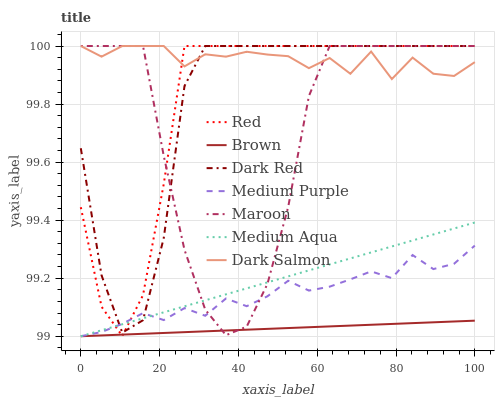Does Dark Red have the minimum area under the curve?
Answer yes or no. No. Does Dark Red have the maximum area under the curve?
Answer yes or no. No. Is Dark Red the smoothest?
Answer yes or no. No. Is Dark Red the roughest?
Answer yes or no. No. Does Dark Red have the lowest value?
Answer yes or no. No. Does Medium Purple have the highest value?
Answer yes or no. No. Is Brown less than Dark Red?
Answer yes or no. Yes. Is Dark Salmon greater than Medium Purple?
Answer yes or no. Yes. Does Brown intersect Dark Red?
Answer yes or no. No. 